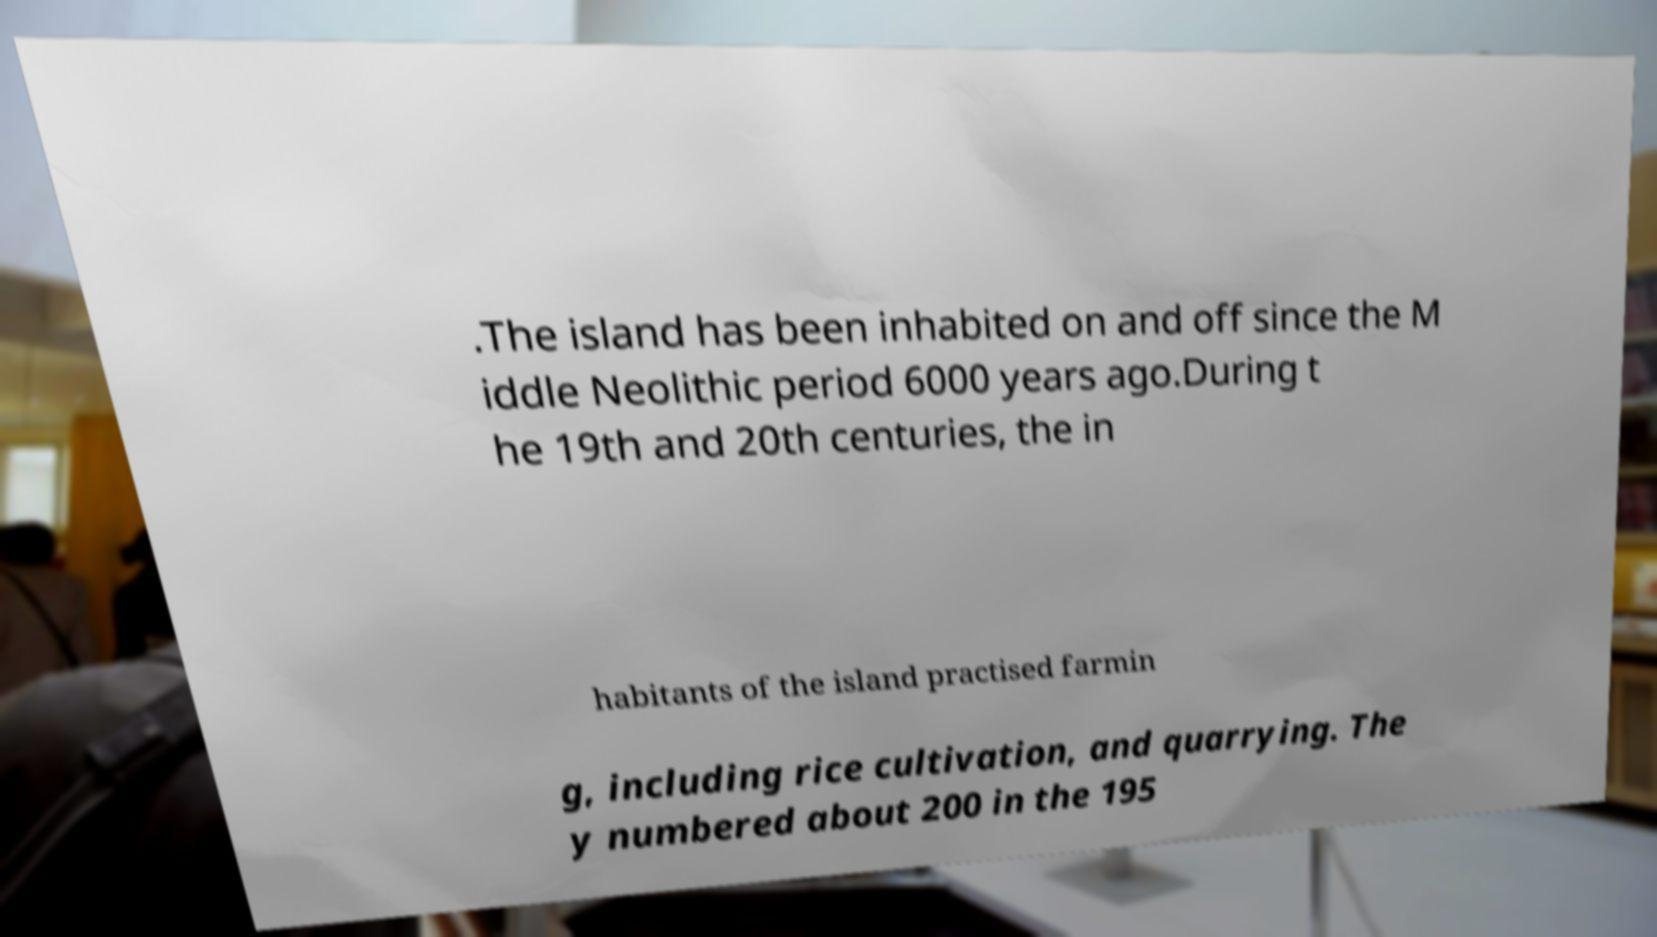Please identify and transcribe the text found in this image. .The island has been inhabited on and off since the M iddle Neolithic period 6000 years ago.During t he 19th and 20th centuries, the in habitants of the island practised farmin g, including rice cultivation, and quarrying. The y numbered about 200 in the 195 